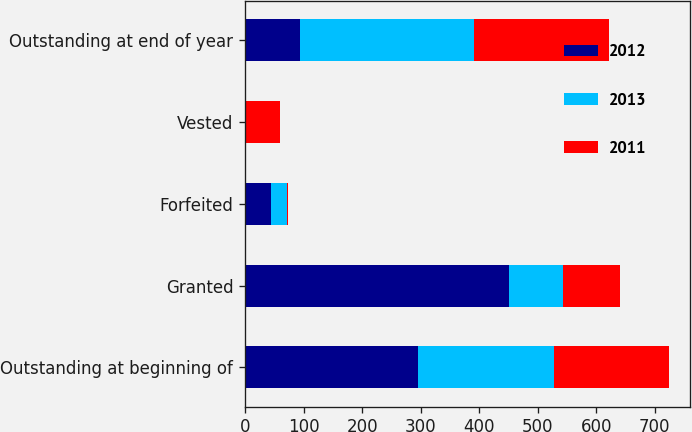<chart> <loc_0><loc_0><loc_500><loc_500><stacked_bar_chart><ecel><fcel>Outstanding at beginning of<fcel>Granted<fcel>Forfeited<fcel>Vested<fcel>Outstanding at end of year<nl><fcel>2012<fcel>296<fcel>451<fcel>44<fcel>1<fcel>94.5<nl><fcel>2013<fcel>232<fcel>92<fcel>27<fcel>1<fcel>296<nl><fcel>2011<fcel>196<fcel>97<fcel>3<fcel>58<fcel>232<nl></chart> 